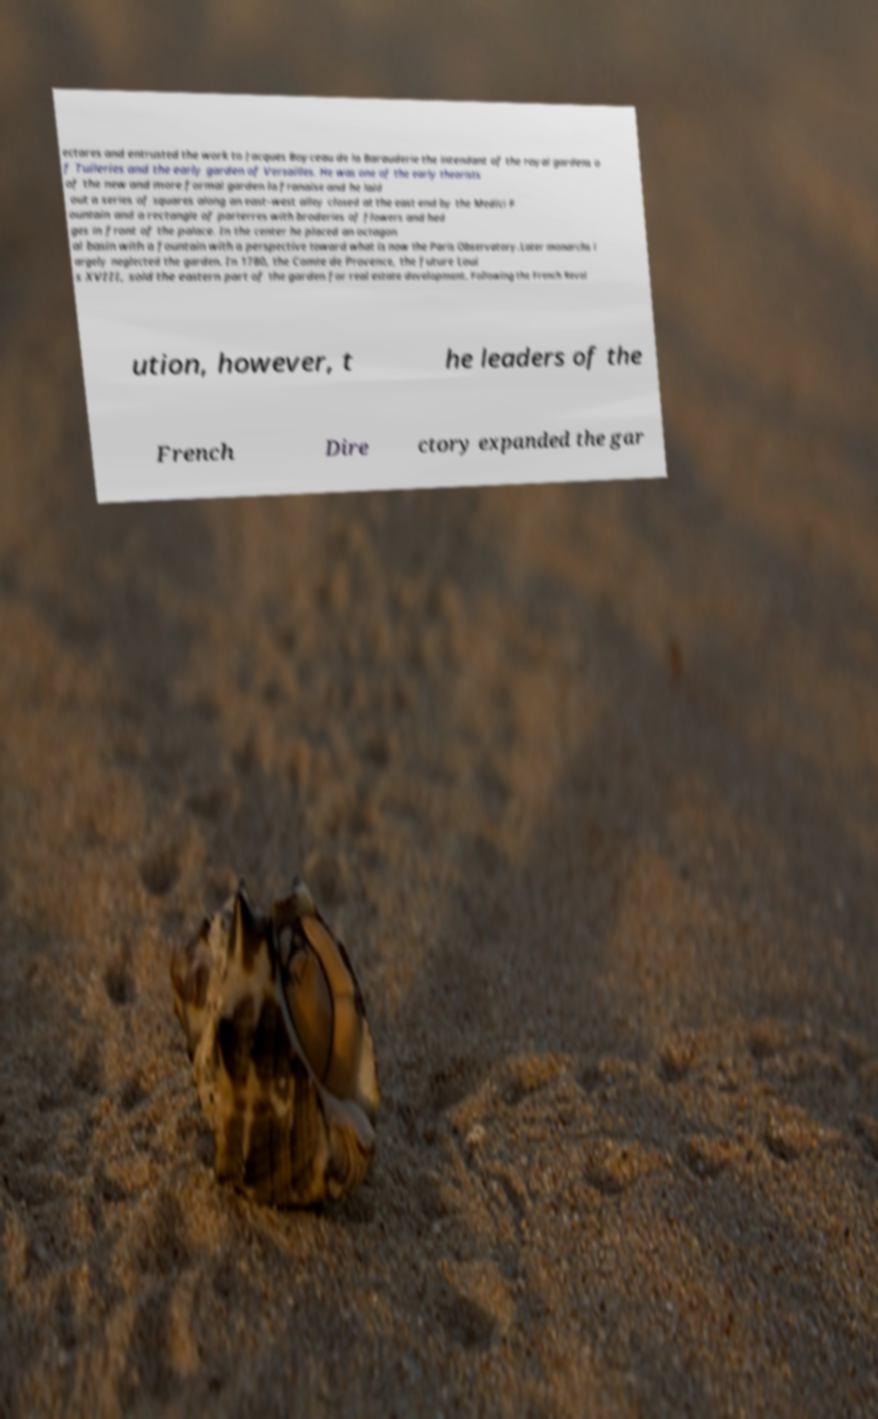For documentation purposes, I need the text within this image transcribed. Could you provide that? ectares and entrusted the work to Jacques Boyceau de la Barauderie the intendant of the royal gardens o f Tuileries and the early garden of Versailles. He was one of the early theorists of the new and more formal garden la franaise and he laid out a series of squares along an east–west alley closed at the east end by the Medici F ountain and a rectangle of parterres with broderies of flowers and hed ges in front of the palace. In the center he placed an octagon al basin with a fountain with a perspective toward what is now the Paris Observatory.Later monarchs l argely neglected the garden. In 1780, the Comte de Provence, the future Loui s XVIII, sold the eastern part of the garden for real estate development. Following the French Revol ution, however, t he leaders of the French Dire ctory expanded the gar 